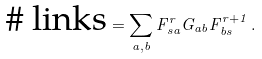<formula> <loc_0><loc_0><loc_500><loc_500>\text {\# links} = \sum _ { a , b } F _ { s a } ^ { r } G _ { a b } F _ { b s } ^ { r + 1 } \, .</formula> 